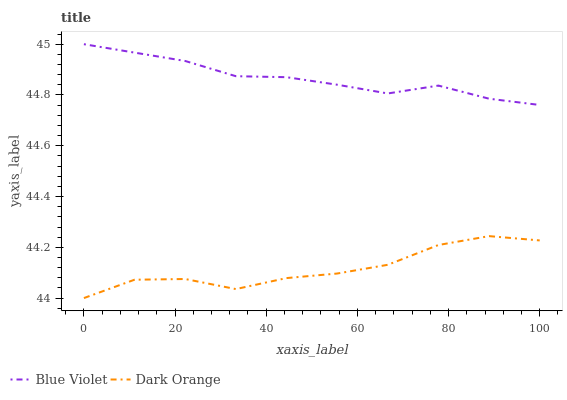Does Dark Orange have the minimum area under the curve?
Answer yes or no. Yes. Does Blue Violet have the maximum area under the curve?
Answer yes or no. Yes. Does Blue Violet have the minimum area under the curve?
Answer yes or no. No. Is Blue Violet the smoothest?
Answer yes or no. Yes. Is Dark Orange the roughest?
Answer yes or no. Yes. Is Blue Violet the roughest?
Answer yes or no. No. Does Dark Orange have the lowest value?
Answer yes or no. Yes. Does Blue Violet have the lowest value?
Answer yes or no. No. Does Blue Violet have the highest value?
Answer yes or no. Yes. Is Dark Orange less than Blue Violet?
Answer yes or no. Yes. Is Blue Violet greater than Dark Orange?
Answer yes or no. Yes. Does Dark Orange intersect Blue Violet?
Answer yes or no. No. 